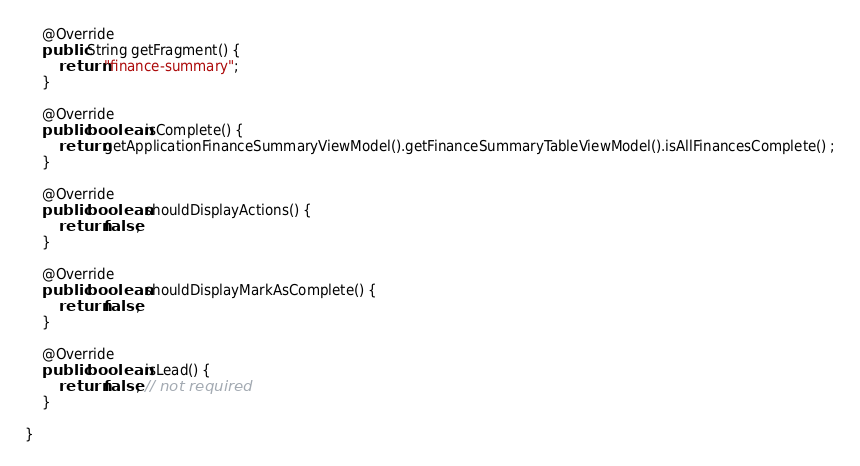Convert code to text. <code><loc_0><loc_0><loc_500><loc_500><_Java_>    @Override
    public String getFragment() {
        return "finance-summary";
    }

    @Override
    public boolean isComplete() {
        return getApplicationFinanceSummaryViewModel().getFinanceSummaryTableViewModel().isAllFinancesComplete() ;
    }

    @Override
    public boolean shouldDisplayActions() {
        return false;
    }

    @Override
    public boolean shouldDisplayMarkAsComplete() {
        return false;
    }

    @Override
    public boolean isLead() {
        return false; // not required
    }

}
</code> 